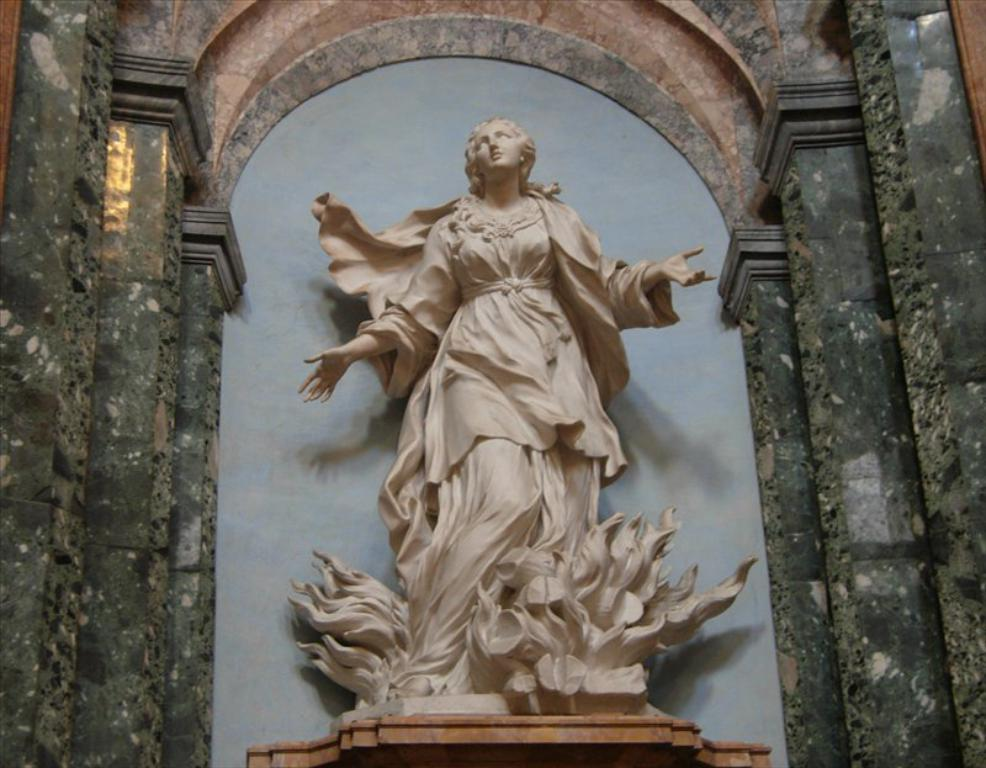What is the main subject in the center of the image? There is a statue in the center of the image. What can be seen near the statue? There are poles adjacent to the statue. What architectural features are present on both sides of the image? There are pillars on both sides of the image. What is located behind the statue? There is a wall behind the statue. What type of music is being played by the statue in the image? The statue is not playing any music in the image; it is a stationary object. 